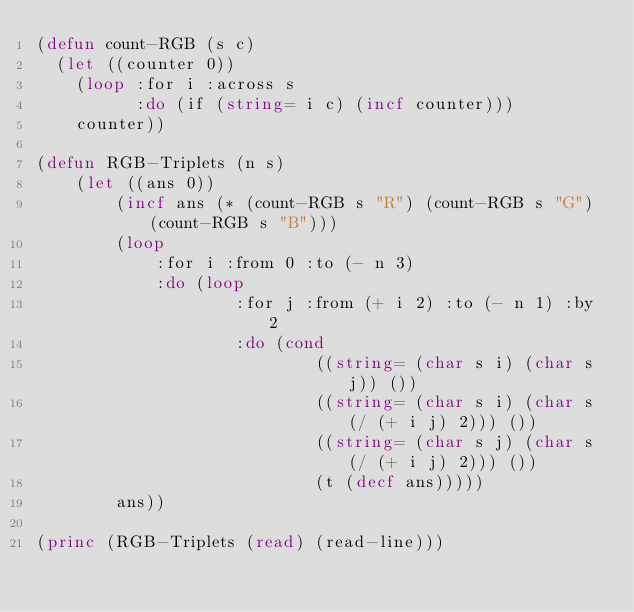Convert code to text. <code><loc_0><loc_0><loc_500><loc_500><_Lisp_>(defun count-RGB (s c)
  (let ((counter 0))
    (loop :for i :across s
          :do (if (string= i c) (incf counter)))
    counter))

(defun RGB-Triplets (n s)
    (let ((ans 0))
        (incf ans (* (count-RGB s "R") (count-RGB s "G") (count-RGB s "B")))
        (loop
            :for i :from 0 :to (- n 3)
            :do (loop
                    :for j :from (+ i 2) :to (- n 1) :by 2
                    :do (cond
                            ((string= (char s i) (char s j)) ())
                            ((string= (char s i) (char s (/ (+ i j) 2))) ())
                            ((string= (char s j) (char s (/ (+ i j) 2))) ())
                            (t (decf ans)))))
        ans))

(princ (RGB-Triplets (read) (read-line)))</code> 